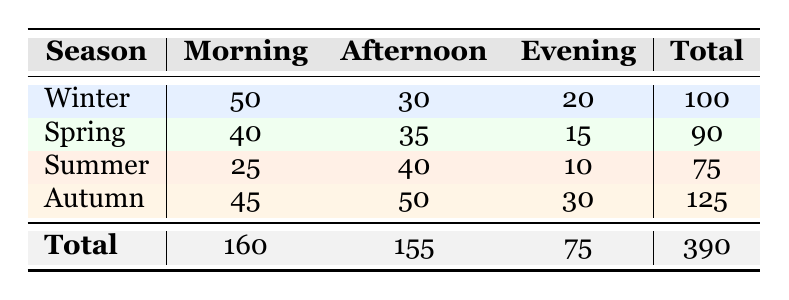What is the total number of coffee orders in Winter? The total number of coffee orders in Winter can be found by adding the order counts for all times of day in that season. The totals are: 50 (Morning) + 30 (Afternoon) + 20 (Evening) = 100.
Answer: 100 Which season had the highest number of coffee orders in the Afternoon? To determine the season with the highest number of coffee orders in the Afternoon, we analyze the order counts in that column: Winter (30), Spring (35), Summer (40), Autumn (50). The highest count is from Autumn with 50.
Answer: Autumn What is the average number of coffee orders during the Evening across all seasons? To find the average number of coffee orders during the Evening, first sum the Evening order counts: 20 (Winter) + 15 (Spring) + 10 (Summer) + 30 (Autumn) = 75. Since there are 4 seasons, we divide 75 by 4 to get 75/4 = 18.75.
Answer: 18.75 Is it true that more coffee orders were made in the Morning than in the Evening across all seasons? To verify this, we need to sum the Morning and Evening orders separately. Morning total: 50 (Winter) + 40 (Spring) + 25 (Summer) + 45 (Autumn) = 160. Evening total: 20 (Winter) + 15 (Spring) + 10 (Summer) + 30 (Autumn) = 75. Since 160 > 75, the statement is true.
Answer: Yes What is the difference in total coffee orders between the season with the least and the most orders? To find this, we first identify the total orders for each season: Winter (100), Spring (90), Summer (75), Autumn (125). The season with the least is Summer (75) and the most is Autumn (125). The difference is 125 - 75 = 50.
Answer: 50 